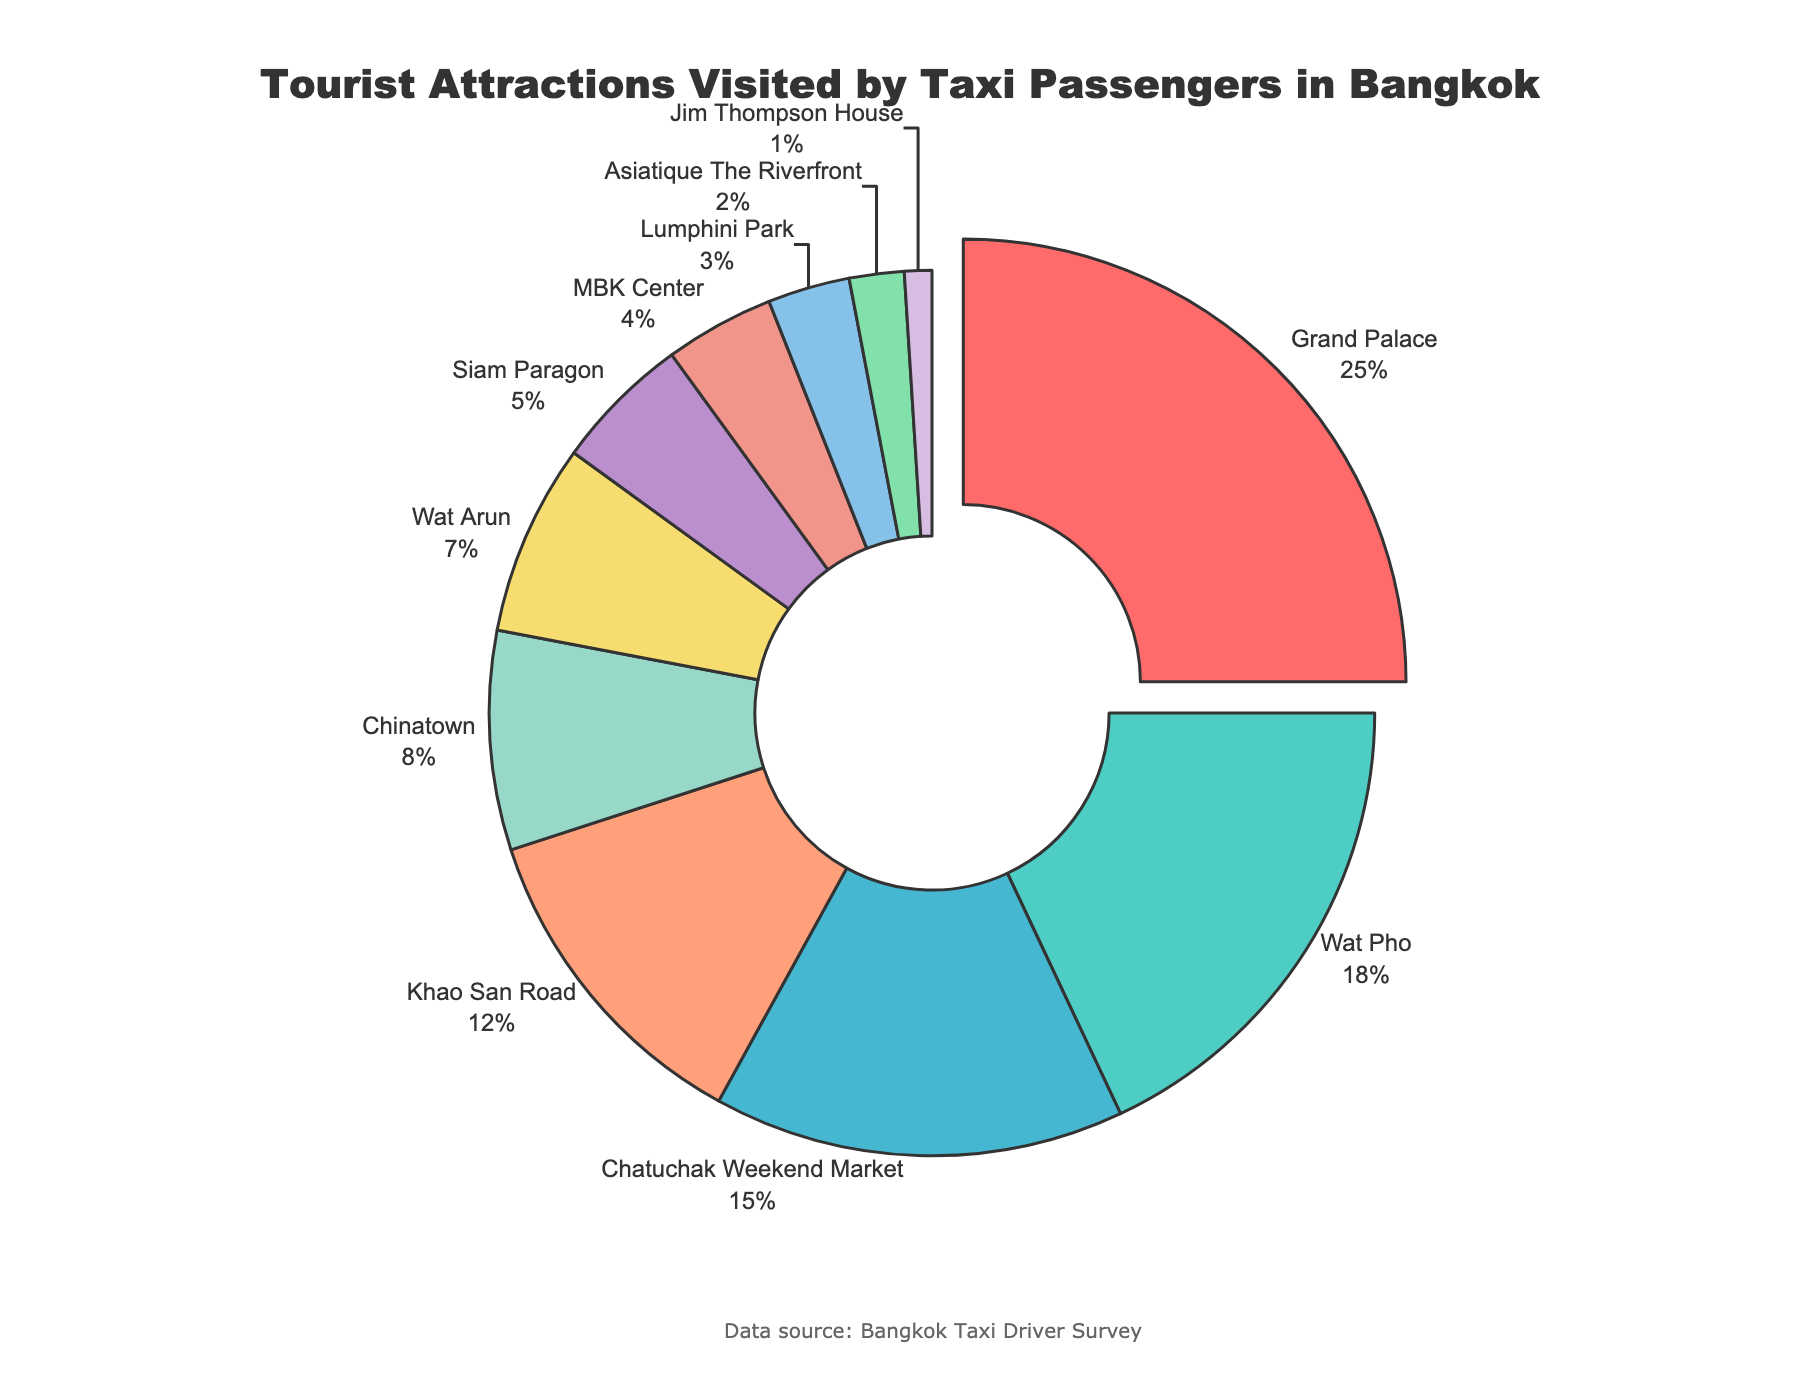What's the largest tourist attraction visited by taxi passengers in terms of percentage? Grand Palace has the largest segment, which is denoted by a 25% slice of the pie chart.
Answer: Grand Palace What percentage of tourists visit Wat Pho compared to the Grand Palace? Wat Pho is visited by 18% of tourists, while the Grand Palace is visited by 25%. The ratio can be calculated as 18/25 = 0.72 or 72%.
Answer: 72% How many tourist attractions have a percentage visit above 10%? Counting the segments above 10% shows Grand Palace (25%), Wat Pho (18%), Chatuchak Weekend Market (15%), and Khao San Road (12%). There are 4 in total.
Answer: 4 Which tourist attraction has the smallest percentage and what is it? The smallest segment in the pie chart represents Jim Thompson House with a 1% visit rate.
Answer: Jim Thompson House What is the combined percentage of visitors to Wat Arun and Chinatown? Adding the percentages for Wat Arun (7%) and Chinatown (8%) results in a combined rate of 7% + 8% = 15%.
Answer: 15% Which two tourist attractions have the least amount of visitors? The two smallest segments are Jim Thompson House (1%) and Asiatique The Riverfront (2%).
Answer: Jim Thompson House and Asiatique The Riverfront Is the percentage of visitors to Siam Paragon higher or lower than that of MBK Center? The percentage of visitors to Siam Paragon (5%) is higher than that of MBK Center (4%).
Answer: Higher What is the difference in the percentage of visitors between Chatuchak Weekend Market and Khao San Road? Subtracting the percentage for Khao San Road (12%) from Chatuchak Weekend Market (15%) gives a difference of 3%.
Answer: 3% If the top three tourist attractions are combined, what percentage of tourists do they account for? The top three attractions are Grand Palace (25%), Wat Pho (18%), and Chatuchak Weekend Market (15%). Their combined percentage is 25% + 18% + 15% = 58%.
Answer: 58% How does the percentage of visitors to Lumphini Park compare visually to that of Siam Paragon? The segment for Lumphini Park (3%) is visually smaller than that for Siam Paragon (5%) on the pie chart.
Answer: Smaller 